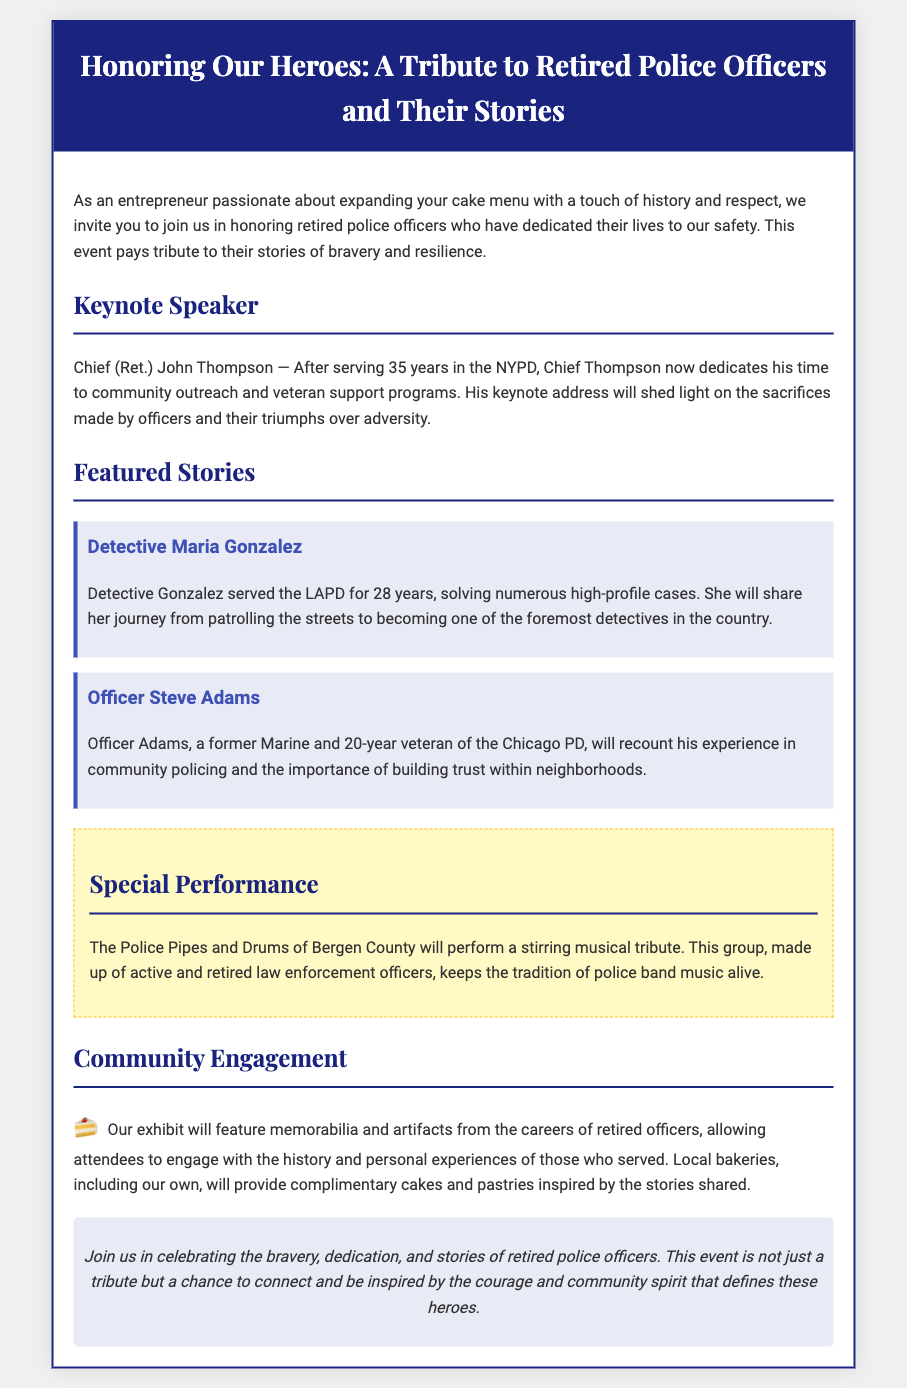What is the title of the event? The title of the event is featured prominently at the top of the document.
Answer: Honoring Our Heroes: A Tribute to Retired Police Officers and Their Stories Who is the keynote speaker? The document provides the name of the keynote speaker in the Keynote Speaker section.
Answer: Chief (Ret.) John Thompson How many years did Detective Maria Gonzalez serve in LAPD? The document specifies the number of years she served right after her name.
Answer: 28 years What type of special performance will occur? The section on Special Performance describes what type of entertainment will happen at the event.
Answer: Musical tribute Which organization will perform during the event? A specific group is mentioned in the Special Performance section about who will perform.
Answer: The Police Pipes and Drums of Bergen County What community activity is included in the event? The document explains what kind of community engagement will take place.
Answer: Exhibit of memorabilia and artifacts How many years did Officer Steve Adams serve Chicago PD? His service length is provided in the description of his featured story.
Answer: 20 years What will local bakeries provide? The Community Engagement section details what local bakeries will bring to the event.
Answer: Complimentary cakes and pastries 